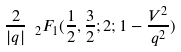Convert formula to latex. <formula><loc_0><loc_0><loc_500><loc_500>\frac { 2 } { | q | } \ _ { 2 } F _ { 1 } ( \frac { 1 } { 2 } , \frac { 3 } { 2 } ; 2 ; 1 - \frac { V ^ { 2 } } { q ^ { 2 } } )</formula> 